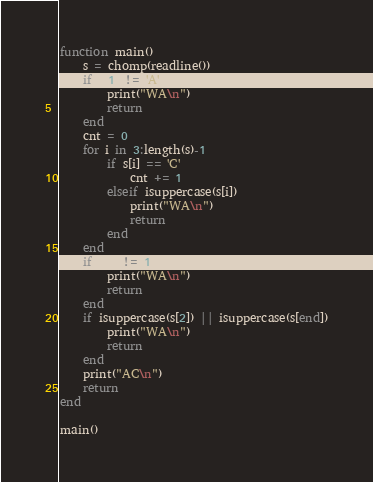Convert code to text. <code><loc_0><loc_0><loc_500><loc_500><_Julia_>function main()
    s = chomp(readline())
    if s[1] != 'A'
        print("WA\n")
        return
    end
    cnt = 0
    for i in 3:length(s)-1
        if s[i] == 'C'
            cnt += 1
        elseif isuppercase(s[i])
            print("WA\n")
            return
        end
    end
    if cnt != 1
        print("WA\n")
        return
    end
    if isuppercase(s[2]) || isuppercase(s[end])
        print("WA\n")
        return
    end
    print("AC\n")
    return
end

main()
</code> 